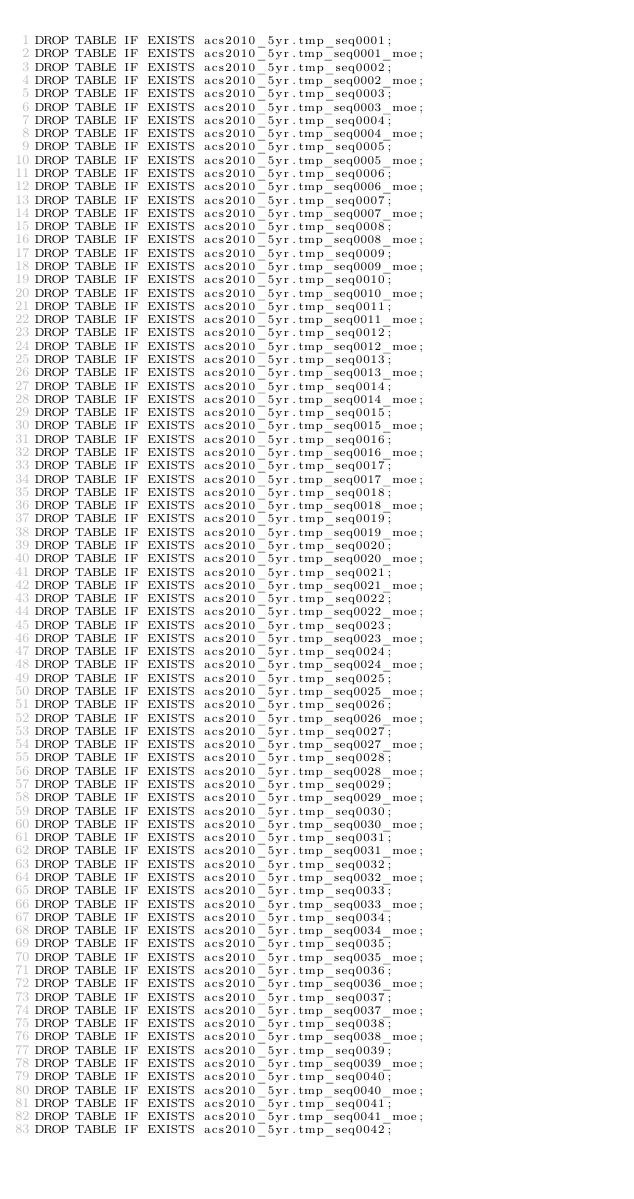<code> <loc_0><loc_0><loc_500><loc_500><_SQL_>DROP TABLE IF EXISTS acs2010_5yr.tmp_seq0001;
DROP TABLE IF EXISTS acs2010_5yr.tmp_seq0001_moe;
DROP TABLE IF EXISTS acs2010_5yr.tmp_seq0002;
DROP TABLE IF EXISTS acs2010_5yr.tmp_seq0002_moe;
DROP TABLE IF EXISTS acs2010_5yr.tmp_seq0003;
DROP TABLE IF EXISTS acs2010_5yr.tmp_seq0003_moe;
DROP TABLE IF EXISTS acs2010_5yr.tmp_seq0004;
DROP TABLE IF EXISTS acs2010_5yr.tmp_seq0004_moe;
DROP TABLE IF EXISTS acs2010_5yr.tmp_seq0005;
DROP TABLE IF EXISTS acs2010_5yr.tmp_seq0005_moe;
DROP TABLE IF EXISTS acs2010_5yr.tmp_seq0006;
DROP TABLE IF EXISTS acs2010_5yr.tmp_seq0006_moe;
DROP TABLE IF EXISTS acs2010_5yr.tmp_seq0007;
DROP TABLE IF EXISTS acs2010_5yr.tmp_seq0007_moe;
DROP TABLE IF EXISTS acs2010_5yr.tmp_seq0008;
DROP TABLE IF EXISTS acs2010_5yr.tmp_seq0008_moe;
DROP TABLE IF EXISTS acs2010_5yr.tmp_seq0009;
DROP TABLE IF EXISTS acs2010_5yr.tmp_seq0009_moe;
DROP TABLE IF EXISTS acs2010_5yr.tmp_seq0010;
DROP TABLE IF EXISTS acs2010_5yr.tmp_seq0010_moe;
DROP TABLE IF EXISTS acs2010_5yr.tmp_seq0011;
DROP TABLE IF EXISTS acs2010_5yr.tmp_seq0011_moe;
DROP TABLE IF EXISTS acs2010_5yr.tmp_seq0012;
DROP TABLE IF EXISTS acs2010_5yr.tmp_seq0012_moe;
DROP TABLE IF EXISTS acs2010_5yr.tmp_seq0013;
DROP TABLE IF EXISTS acs2010_5yr.tmp_seq0013_moe;
DROP TABLE IF EXISTS acs2010_5yr.tmp_seq0014;
DROP TABLE IF EXISTS acs2010_5yr.tmp_seq0014_moe;
DROP TABLE IF EXISTS acs2010_5yr.tmp_seq0015;
DROP TABLE IF EXISTS acs2010_5yr.tmp_seq0015_moe;
DROP TABLE IF EXISTS acs2010_5yr.tmp_seq0016;
DROP TABLE IF EXISTS acs2010_5yr.tmp_seq0016_moe;
DROP TABLE IF EXISTS acs2010_5yr.tmp_seq0017;
DROP TABLE IF EXISTS acs2010_5yr.tmp_seq0017_moe;
DROP TABLE IF EXISTS acs2010_5yr.tmp_seq0018;
DROP TABLE IF EXISTS acs2010_5yr.tmp_seq0018_moe;
DROP TABLE IF EXISTS acs2010_5yr.tmp_seq0019;
DROP TABLE IF EXISTS acs2010_5yr.tmp_seq0019_moe;
DROP TABLE IF EXISTS acs2010_5yr.tmp_seq0020;
DROP TABLE IF EXISTS acs2010_5yr.tmp_seq0020_moe;
DROP TABLE IF EXISTS acs2010_5yr.tmp_seq0021;
DROP TABLE IF EXISTS acs2010_5yr.tmp_seq0021_moe;
DROP TABLE IF EXISTS acs2010_5yr.tmp_seq0022;
DROP TABLE IF EXISTS acs2010_5yr.tmp_seq0022_moe;
DROP TABLE IF EXISTS acs2010_5yr.tmp_seq0023;
DROP TABLE IF EXISTS acs2010_5yr.tmp_seq0023_moe;
DROP TABLE IF EXISTS acs2010_5yr.tmp_seq0024;
DROP TABLE IF EXISTS acs2010_5yr.tmp_seq0024_moe;
DROP TABLE IF EXISTS acs2010_5yr.tmp_seq0025;
DROP TABLE IF EXISTS acs2010_5yr.tmp_seq0025_moe;
DROP TABLE IF EXISTS acs2010_5yr.tmp_seq0026;
DROP TABLE IF EXISTS acs2010_5yr.tmp_seq0026_moe;
DROP TABLE IF EXISTS acs2010_5yr.tmp_seq0027;
DROP TABLE IF EXISTS acs2010_5yr.tmp_seq0027_moe;
DROP TABLE IF EXISTS acs2010_5yr.tmp_seq0028;
DROP TABLE IF EXISTS acs2010_5yr.tmp_seq0028_moe;
DROP TABLE IF EXISTS acs2010_5yr.tmp_seq0029;
DROP TABLE IF EXISTS acs2010_5yr.tmp_seq0029_moe;
DROP TABLE IF EXISTS acs2010_5yr.tmp_seq0030;
DROP TABLE IF EXISTS acs2010_5yr.tmp_seq0030_moe;
DROP TABLE IF EXISTS acs2010_5yr.tmp_seq0031;
DROP TABLE IF EXISTS acs2010_5yr.tmp_seq0031_moe;
DROP TABLE IF EXISTS acs2010_5yr.tmp_seq0032;
DROP TABLE IF EXISTS acs2010_5yr.tmp_seq0032_moe;
DROP TABLE IF EXISTS acs2010_5yr.tmp_seq0033;
DROP TABLE IF EXISTS acs2010_5yr.tmp_seq0033_moe;
DROP TABLE IF EXISTS acs2010_5yr.tmp_seq0034;
DROP TABLE IF EXISTS acs2010_5yr.tmp_seq0034_moe;
DROP TABLE IF EXISTS acs2010_5yr.tmp_seq0035;
DROP TABLE IF EXISTS acs2010_5yr.tmp_seq0035_moe;
DROP TABLE IF EXISTS acs2010_5yr.tmp_seq0036;
DROP TABLE IF EXISTS acs2010_5yr.tmp_seq0036_moe;
DROP TABLE IF EXISTS acs2010_5yr.tmp_seq0037;
DROP TABLE IF EXISTS acs2010_5yr.tmp_seq0037_moe;
DROP TABLE IF EXISTS acs2010_5yr.tmp_seq0038;
DROP TABLE IF EXISTS acs2010_5yr.tmp_seq0038_moe;
DROP TABLE IF EXISTS acs2010_5yr.tmp_seq0039;
DROP TABLE IF EXISTS acs2010_5yr.tmp_seq0039_moe;
DROP TABLE IF EXISTS acs2010_5yr.tmp_seq0040;
DROP TABLE IF EXISTS acs2010_5yr.tmp_seq0040_moe;
DROP TABLE IF EXISTS acs2010_5yr.tmp_seq0041;
DROP TABLE IF EXISTS acs2010_5yr.tmp_seq0041_moe;
DROP TABLE IF EXISTS acs2010_5yr.tmp_seq0042;</code> 